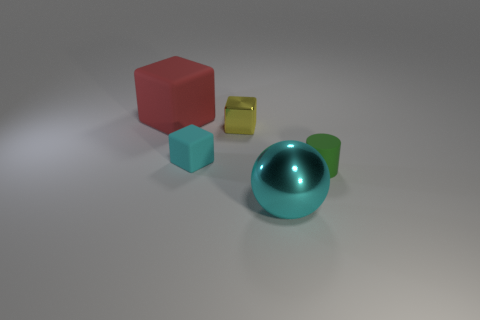Add 4 tiny red rubber cylinders. How many objects exist? 9 Subtract all spheres. How many objects are left? 4 Add 1 large cyan balls. How many large cyan balls are left? 2 Add 2 small matte objects. How many small matte objects exist? 4 Subtract 1 cyan spheres. How many objects are left? 4 Subtract all small cyan rubber cubes. Subtract all metallic spheres. How many objects are left? 3 